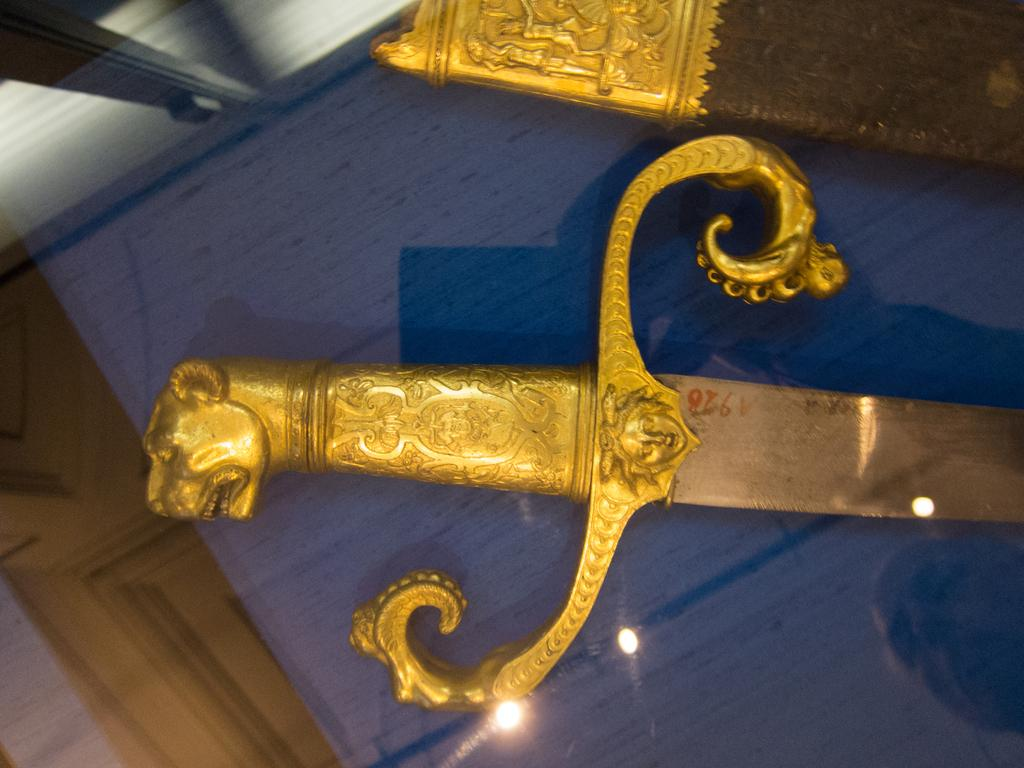What object is present in the image? There is a sword in the image. How is the sword being displayed or protected? The sword is inside a glass box. Can you describe any visual effects present in the image? Light reflection is visible on the glass. What type of dress is hanging from the sword in the image? There is no dress present in the image; the sword is inside a glass box. 